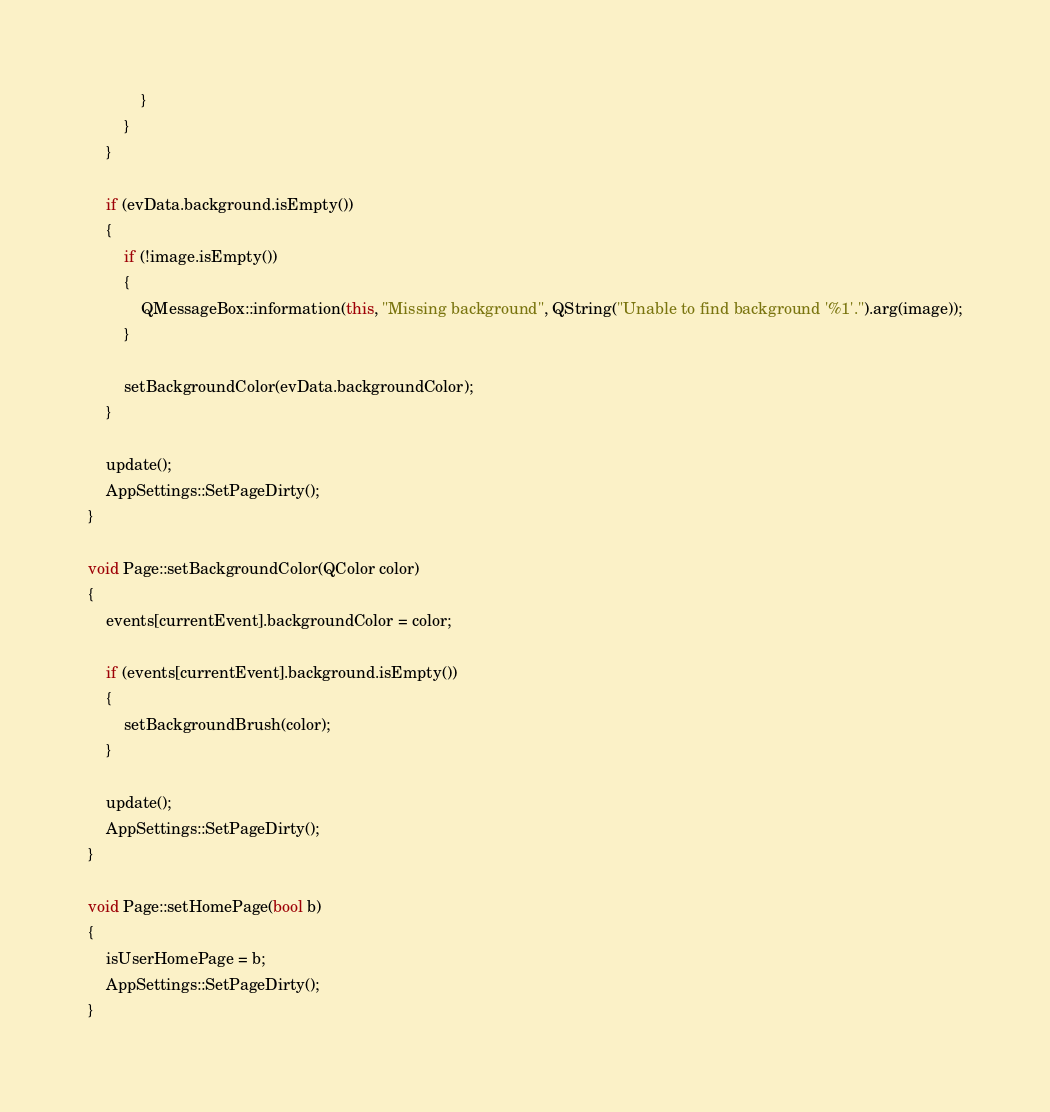Convert code to text. <code><loc_0><loc_0><loc_500><loc_500><_C++_>            }
        }
    }

    if (evData.background.isEmpty())
    {
        if (!image.isEmpty())
        {
            QMessageBox::information(this, "Missing background", QString("Unable to find background '%1'.").arg(image));
        }

        setBackgroundColor(evData.backgroundColor);
    }

    update();
    AppSettings::SetPageDirty();
}

void Page::setBackgroundColor(QColor color)
{
    events[currentEvent].backgroundColor = color;

    if (events[currentEvent].background.isEmpty())
    {
        setBackgroundBrush(color);
    }

    update();
    AppSettings::SetPageDirty();
}

void Page::setHomePage(bool b)
{
    isUserHomePage = b;
    AppSettings::SetPageDirty();
}
</code> 